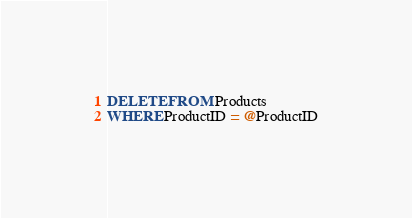Convert code to text. <code><loc_0><loc_0><loc_500><loc_500><_SQL_>DELETE FROM Products
WHERE ProductID = @ProductID</code> 